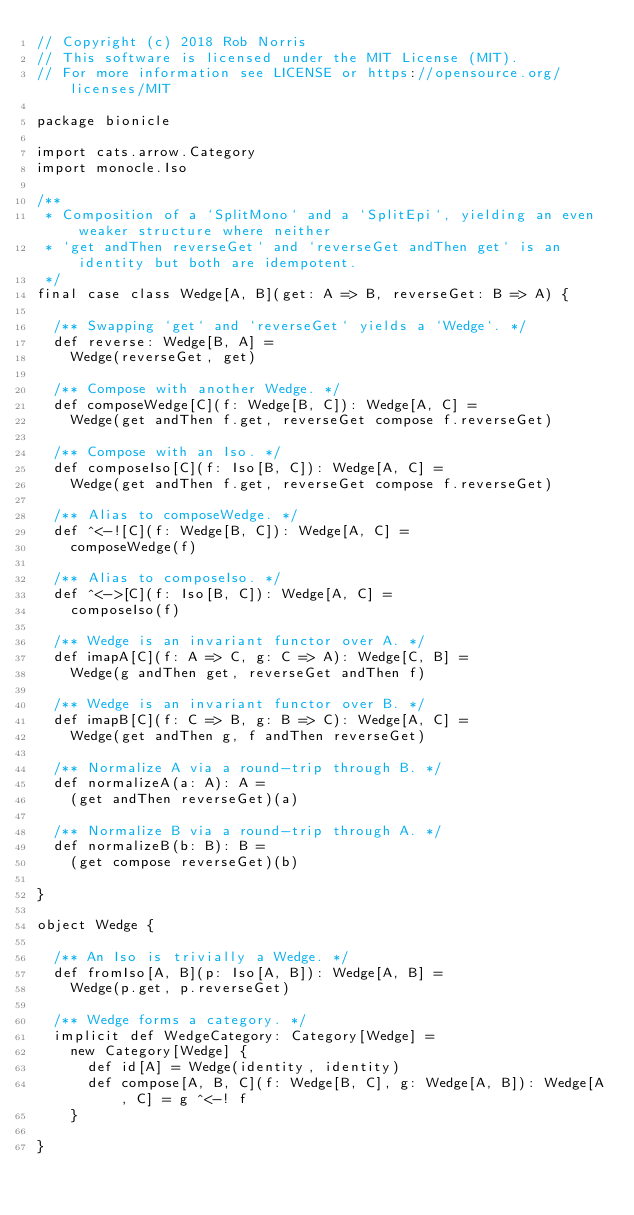Convert code to text. <code><loc_0><loc_0><loc_500><loc_500><_Scala_>// Copyright (c) 2018 Rob Norris
// This software is licensed under the MIT License (MIT).
// For more information see LICENSE or https://opensource.org/licenses/MIT

package bionicle

import cats.arrow.Category
import monocle.Iso

/**
 * Composition of a `SplitMono` and a `SplitEpi`, yielding an even weaker structure where neither
 * `get andThen reverseGet` and `reverseGet andThen get` is an identity but both are idempotent.
 */
final case class Wedge[A, B](get: A => B, reverseGet: B => A) {

  /** Swapping `get` and `reverseGet` yields a `Wedge`. */
  def reverse: Wedge[B, A] =
    Wedge(reverseGet, get)

  /** Compose with another Wedge. */
  def composeWedge[C](f: Wedge[B, C]): Wedge[A, C] =
    Wedge(get andThen f.get, reverseGet compose f.reverseGet)

  /** Compose with an Iso. */
  def composeIso[C](f: Iso[B, C]): Wedge[A, C] =
    Wedge(get andThen f.get, reverseGet compose f.reverseGet)

  /** Alias to composeWedge. */
  def ^<-![C](f: Wedge[B, C]): Wedge[A, C] =
    composeWedge(f)

  /** Alias to composeIso. */
  def ^<->[C](f: Iso[B, C]): Wedge[A, C] =
    composeIso(f)

  /** Wedge is an invariant functor over A. */
  def imapA[C](f: A => C, g: C => A): Wedge[C, B] =
    Wedge(g andThen get, reverseGet andThen f)

  /** Wedge is an invariant functor over B. */
  def imapB[C](f: C => B, g: B => C): Wedge[A, C] =
    Wedge(get andThen g, f andThen reverseGet)

  /** Normalize A via a round-trip through B. */
  def normalizeA(a: A): A =
    (get andThen reverseGet)(a)

  /** Normalize B via a round-trip through A. */
  def normalizeB(b: B): B =
    (get compose reverseGet)(b)

}

object Wedge {

  /** An Iso is trivially a Wedge. */
  def fromIso[A, B](p: Iso[A, B]): Wedge[A, B] =
    Wedge(p.get, p.reverseGet)

  /** Wedge forms a category. */
  implicit def WedgeCategory: Category[Wedge] =
    new Category[Wedge] {
      def id[A] = Wedge(identity, identity)
      def compose[A, B, C](f: Wedge[B, C], g: Wedge[A, B]): Wedge[A, C] = g ^<-! f
    }

}
</code> 